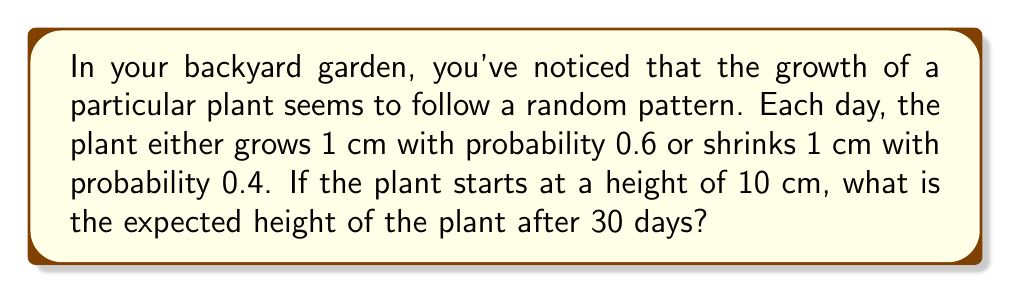Could you help me with this problem? Let's approach this step-by-step:

1) This scenario describes a simple random walk model. Each day, the plant's height changes by either +1 cm or -1 cm.

2) The expected change in height per day is:
   $$(0.6 \times 1) + (0.4 \times (-1)) = 0.6 - 0.4 = 0.2\text{ cm}$$

3) Over 30 days, the expected total change in height is:
   $$30 \times 0.2 = 6\text{ cm}$$

4) The plant starts at 10 cm, so after 30 days, the expected height is:
   $$10\text{ cm} + 6\text{ cm} = 16\text{ cm}$$

5) We can also express this using the formula for the expected position in a random walk:
   $$E[X_n] = X_0 + n(p-q)$$
   Where:
   $X_0$ is the initial position (10 cm)
   $n$ is the number of steps (30 days)
   $p$ is the probability of moving up (0.6)
   $q$ is the probability of moving down (0.4)

   $$E[X_{30}] = 10 + 30(0.6-0.4) = 10 + 30(0.2) = 10 + 6 = 16\text{ cm}$$

Therefore, the expected height of the plant after 30 days is 16 cm.
Answer: 16 cm 